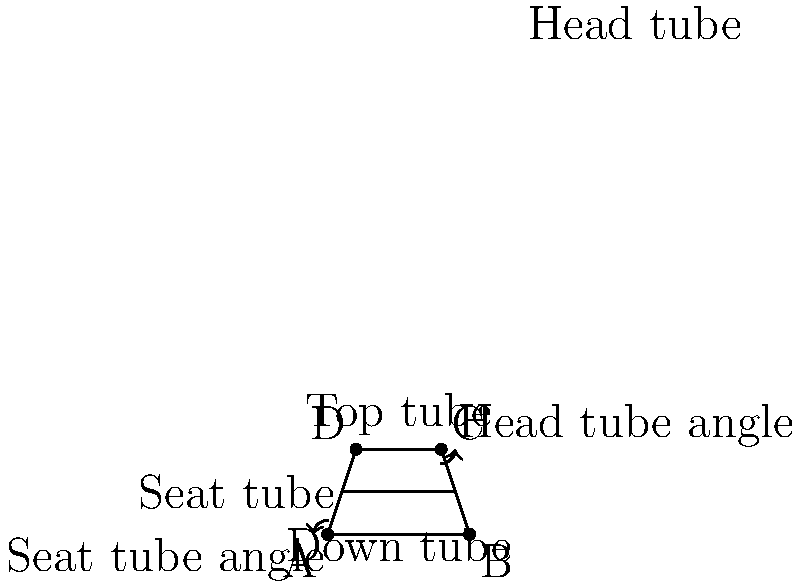As a cycling event organizer, you're designing a new racing bicycle frame. Which combination of frame geometry factors would likely result in the most aerodynamic and responsive racing bicycle for a criterium race?

a) Steeper head tube angle, longer top tube
b) Slacker head tube angle, shorter top tube
c) Steeper seat tube angle, shorter chainstays
d) Slacker seat tube angle, longer wheelbase To determine the optimal frame geometry for a criterium racing bicycle, we need to consider the following factors:

1. Head tube angle: A steeper head tube angle (closer to vertical) provides quicker steering response, which is crucial for navigating tight corners in criterium races.

2. Top tube length: A slightly longer top tube allows for a more aerodynamic riding position, reducing wind resistance.

3. Seat tube angle: A steeper seat tube angle places the rider in a more forward position, improving power transfer and aerodynamics.

4. Chainstay length: Shorter chainstays result in a more responsive bike, allowing for quicker acceleration out of corners.

5. Wheelbase: A shorter wheelbase improves maneuverability, which is essential for criterium races with frequent turns.

Analyzing the options:

a) Steeper head tube angle and longer top tube: This combination provides quick steering response and improved aerodynamics, which are both beneficial for criterium racing.

b) Slacker head tube angle and shorter top tube: This would result in slower steering response and a less aerodynamic position, which is not ideal for criterium racing.

c) Steeper seat tube angle and shorter chainstays: This combination improves power transfer, responsiveness, and maneuverability, all of which are advantageous for criterium racing.

d) Slacker seat tube angle and longer wheelbase: This would result in less efficient power transfer and reduced maneuverability, which is not suitable for criterium racing.

Considering these factors, the best combination for a criterium racing bicycle would be option (c), as it provides the most responsive and agile geometry for the tight corners and frequent accelerations typical in criterium races.
Answer: c) Steeper seat tube angle, shorter chainstays 